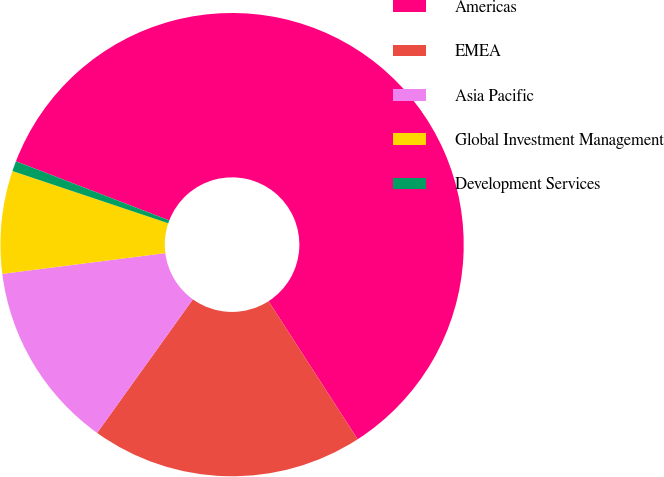<chart> <loc_0><loc_0><loc_500><loc_500><pie_chart><fcel>Americas<fcel>EMEA<fcel>Asia Pacific<fcel>Global Investment Management<fcel>Development Services<nl><fcel>60.02%<fcel>19.02%<fcel>13.09%<fcel>7.16%<fcel>0.71%<nl></chart> 